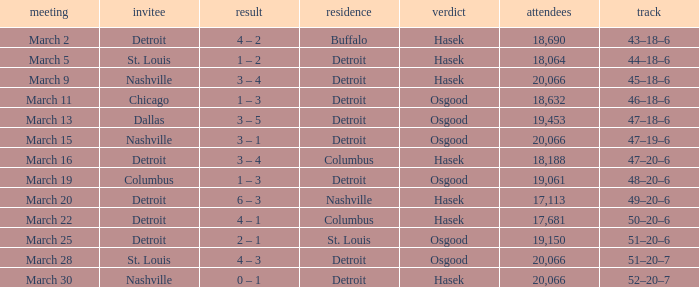What was the decision of the Red Wings game when they had a record of 45–18–6? Hasek. 